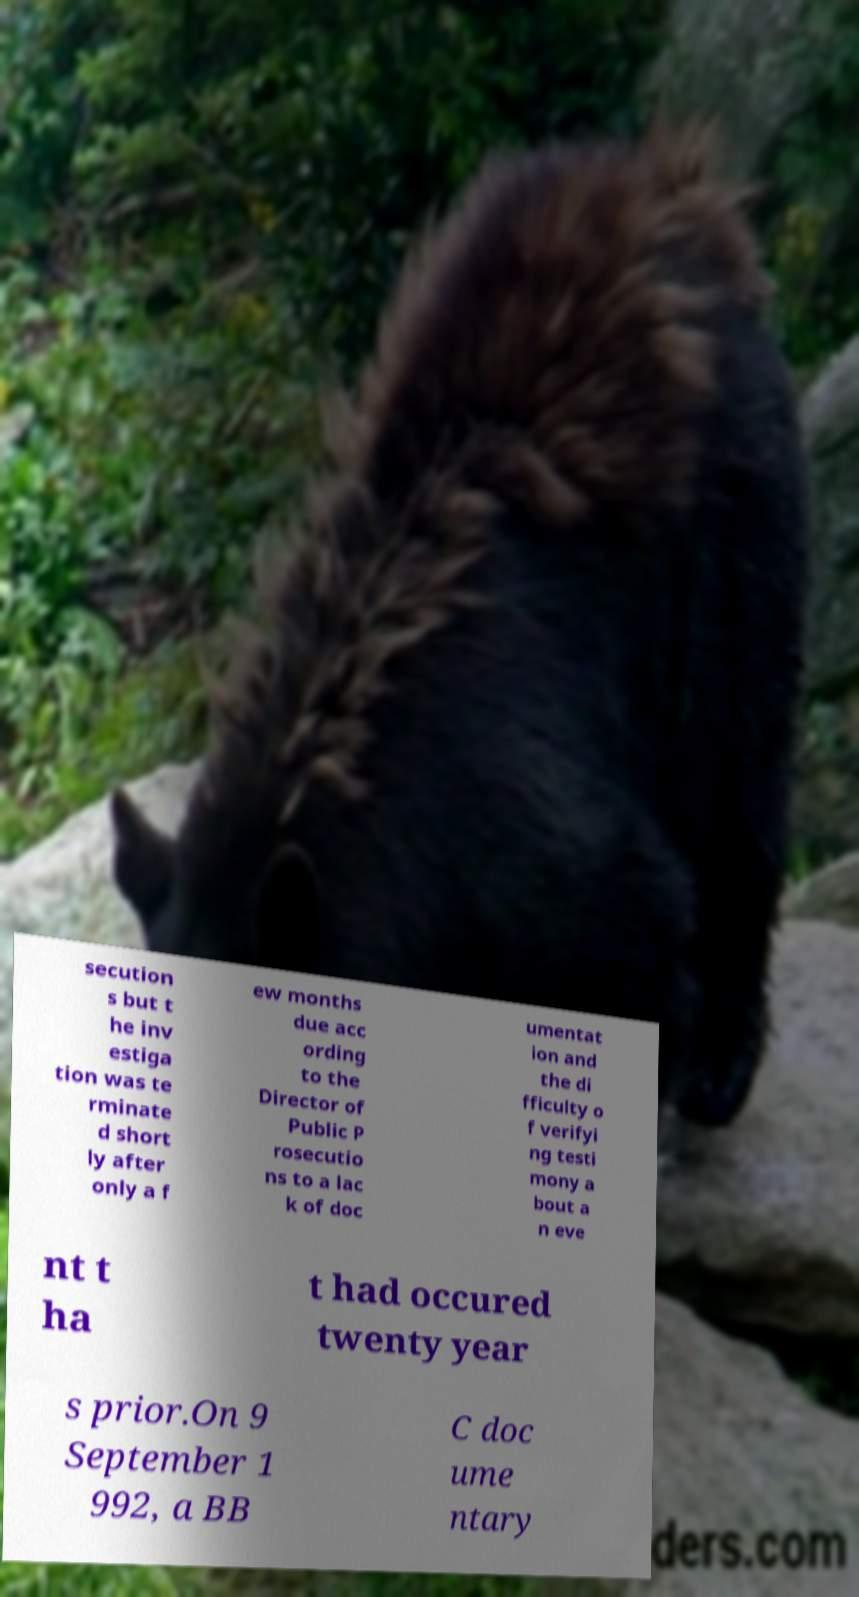I need the written content from this picture converted into text. Can you do that? secution s but t he inv estiga tion was te rminate d short ly after only a f ew months due acc ording to the Director of Public P rosecutio ns to a lac k of doc umentat ion and the di fficulty o f verifyi ng testi mony a bout a n eve nt t ha t had occured twenty year s prior.On 9 September 1 992, a BB C doc ume ntary 